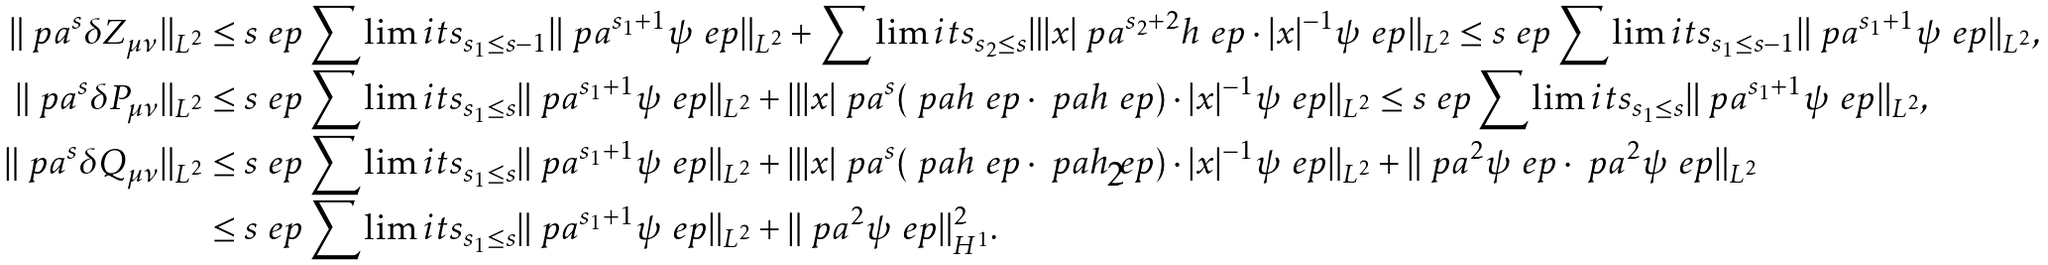<formula> <loc_0><loc_0><loc_500><loc_500>\| \ p a ^ { s } \delta Z _ { \mu \nu } \| _ { L ^ { 2 } } & \leq s \ e p \sum \lim i t s _ { s _ { 1 } \leq s - 1 } \| \ p a ^ { s _ { 1 } + 1 } \psi ^ { \ } e p \| _ { L ^ { 2 } } + \sum \lim i t s _ { s _ { 2 } \leq s } \| | x | \ p a ^ { s _ { 2 } + 2 } h ^ { \ } e p \cdot | x | ^ { - 1 } \psi ^ { \ } e p \| _ { L ^ { 2 } } \leq s \ e p \sum \lim i t s _ { s _ { 1 } \leq s - 1 } \| \ p a ^ { s _ { 1 } + 1 } \psi ^ { \ } e p \| _ { L ^ { 2 } } , \\ \| \ p a ^ { s } \delta P _ { \mu \nu } \| _ { L ^ { 2 } } & \leq s \ e p \sum \lim i t s _ { s _ { 1 } \leq s } \| \ p a ^ { s _ { 1 } + 1 } \psi ^ { \ } e p \| _ { L ^ { 2 } } + \| | x | \ p a ^ { s } ( \ p a h ^ { \ } e p \cdot \ p a h ^ { \ } e p ) \cdot | x | ^ { - 1 } \psi ^ { \ } e p \| _ { L ^ { 2 } } \leq s \ e p \sum \lim i t s _ { s _ { 1 } \leq s } \| \ p a ^ { s _ { 1 } + 1 } \psi ^ { \ } e p \| _ { L ^ { 2 } } , \\ \| \ p a ^ { s } \delta Q _ { \mu \nu } \| _ { L ^ { 2 } } & \leq s \ e p \sum \lim i t s _ { s _ { 1 } \leq s } \| \ p a ^ { s _ { 1 } + 1 } \psi ^ { \ } e p \| _ { L ^ { 2 } } + \| | x | \ p a ^ { s } ( \ p a h ^ { \ } e p \cdot \ p a h ^ { \ } e p ) \cdot | x | ^ { - 1 } \psi ^ { \ } e p \| _ { L ^ { 2 } } + \| \ p a ^ { 2 } \psi ^ { \ } e p \cdot \ p a ^ { 2 } \psi ^ { \ } e p \| _ { L ^ { 2 } } \\ & \leq s \ e p \sum \lim i t s _ { s _ { 1 } \leq s } \| \ p a ^ { s _ { 1 } + 1 } \psi ^ { \ } e p \| _ { L ^ { 2 } } + \| \ p a ^ { 2 } \psi ^ { \ } e p \| _ { H ^ { 1 } } ^ { 2 } .</formula> 